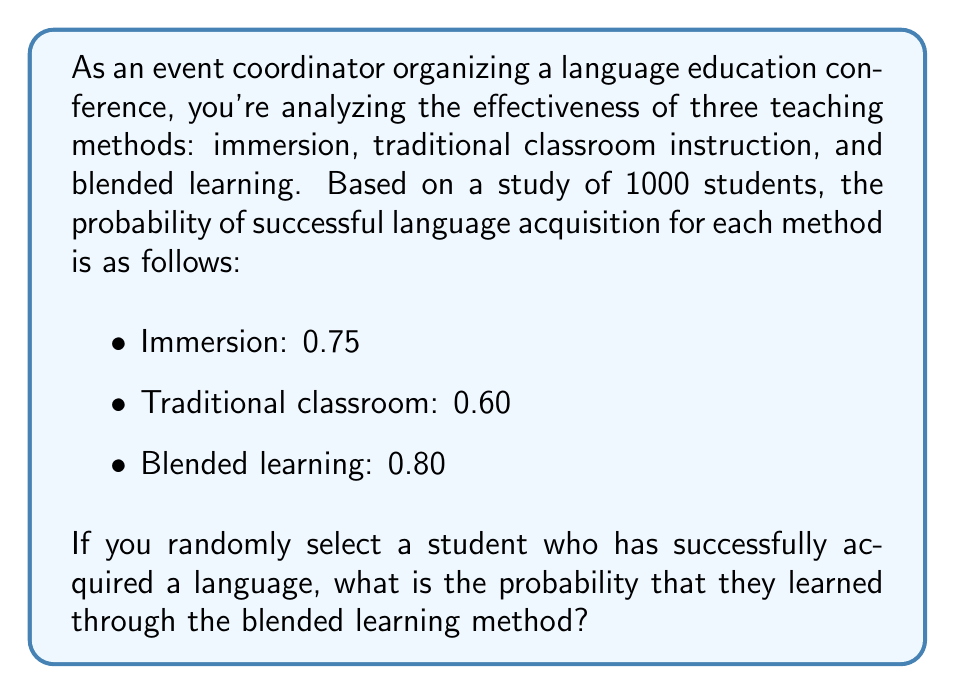Could you help me with this problem? To solve this problem, we'll use Bayes' theorem. Let's define our events:

A: Student successfully acquired the language
B: Student learned through blended learning

We want to find P(B|A), which is the probability that a student learned through blended learning given that they successfully acquired the language.

Bayes' theorem states:

$$ P(B|A) = \frac{P(A|B) \cdot P(B)}{P(A)} $$

We're given:
P(A|B) = 0.80 (probability of success given blended learning)
P(B) = 1/3 (assuming equal distribution of students across methods)

We need to calculate P(A):
$$ P(A) = P(A|B_1)P(B_1) + P(A|B_2)P(B_2) + P(A|B_3)P(B_3) $$
Where B_1, B_2, and B_3 represent the three teaching methods.

$$ P(A) = 0.75 \cdot \frac{1}{3} + 0.60 \cdot \frac{1}{3} + 0.80 \cdot \frac{1}{3} = 0.7167 $$

Now we can apply Bayes' theorem:

$$ P(B|A) = \frac{0.80 \cdot \frac{1}{3}}{0.7167} = \frac{0.2667}{0.7167} \approx 0.3721 $$
Answer: The probability that a randomly selected student who successfully acquired a language learned through the blended learning method is approximately 0.3721 or 37.21%. 